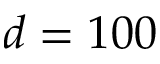Convert formula to latex. <formula><loc_0><loc_0><loc_500><loc_500>d = 1 0 0</formula> 